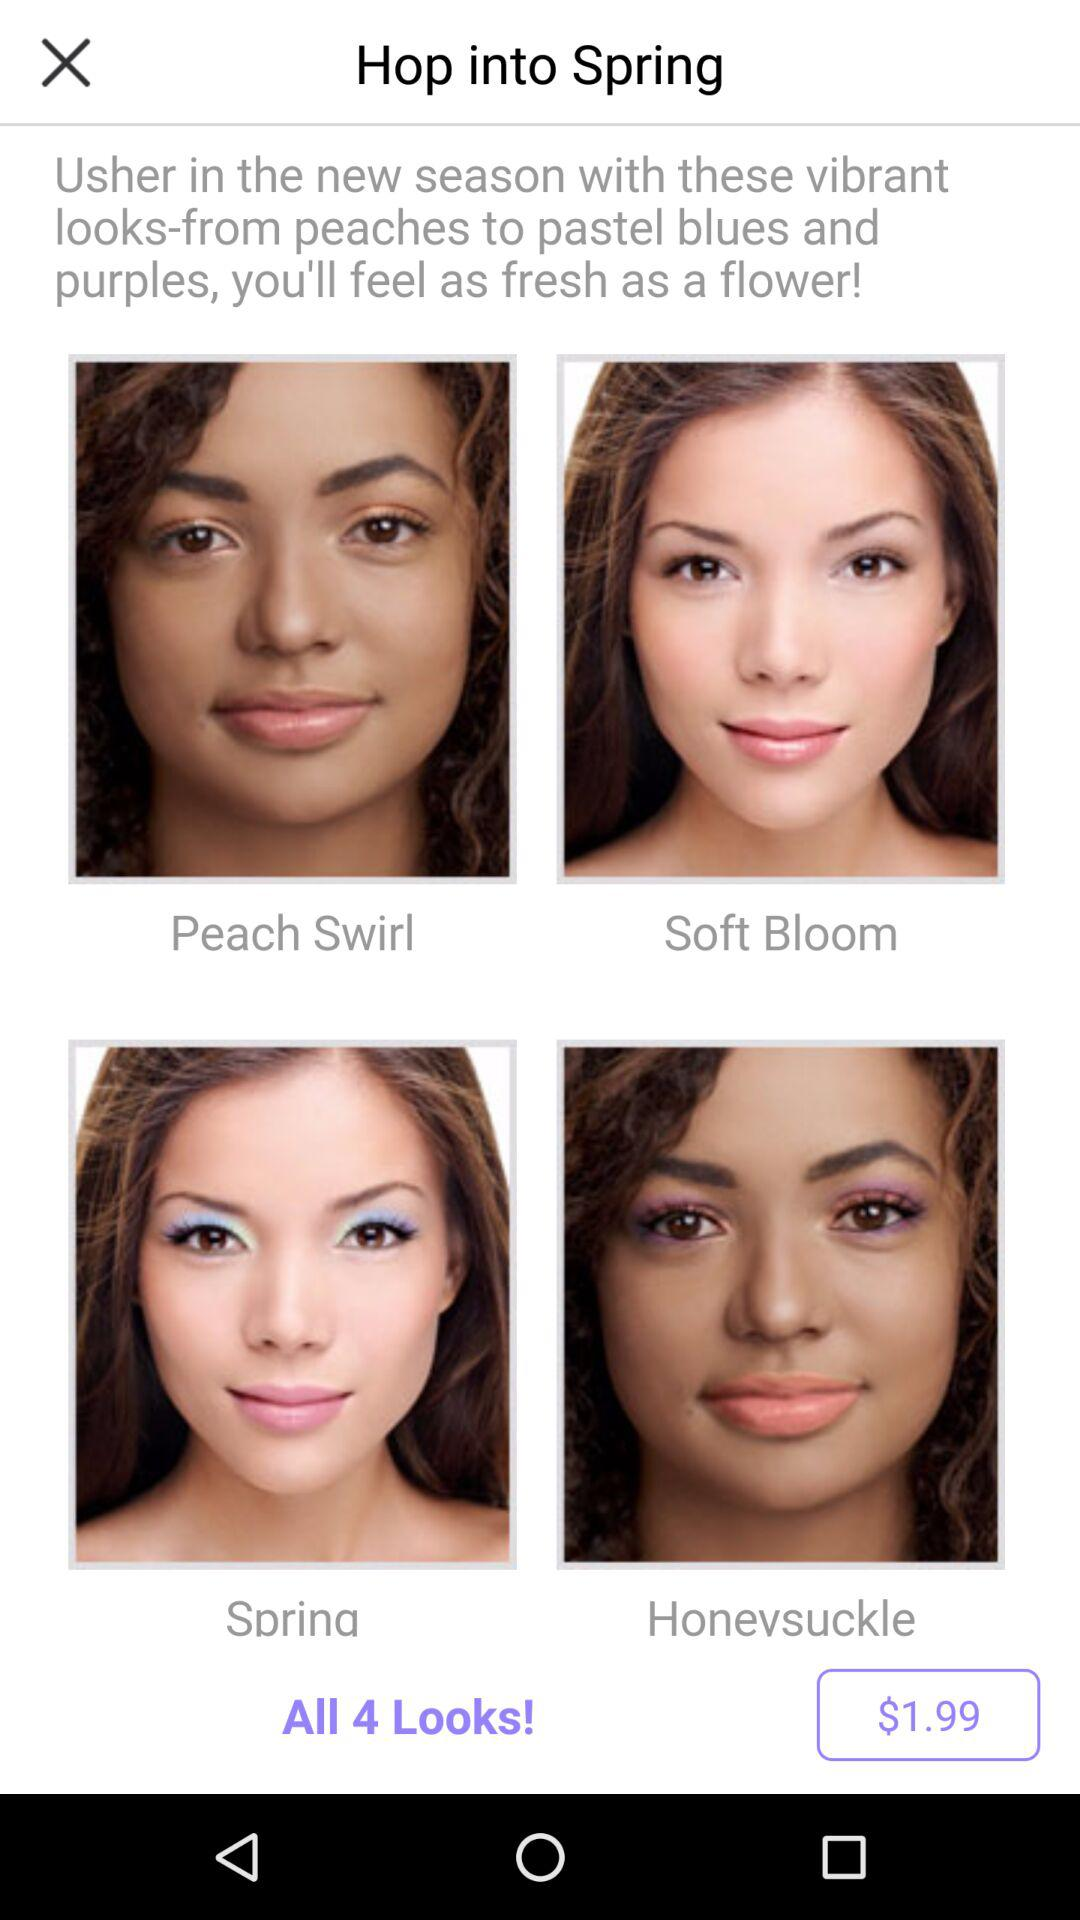What are the names of the 4 looks? The names of the 4 looks are peach swirl, soft bloom, spring and honeysuckle. 